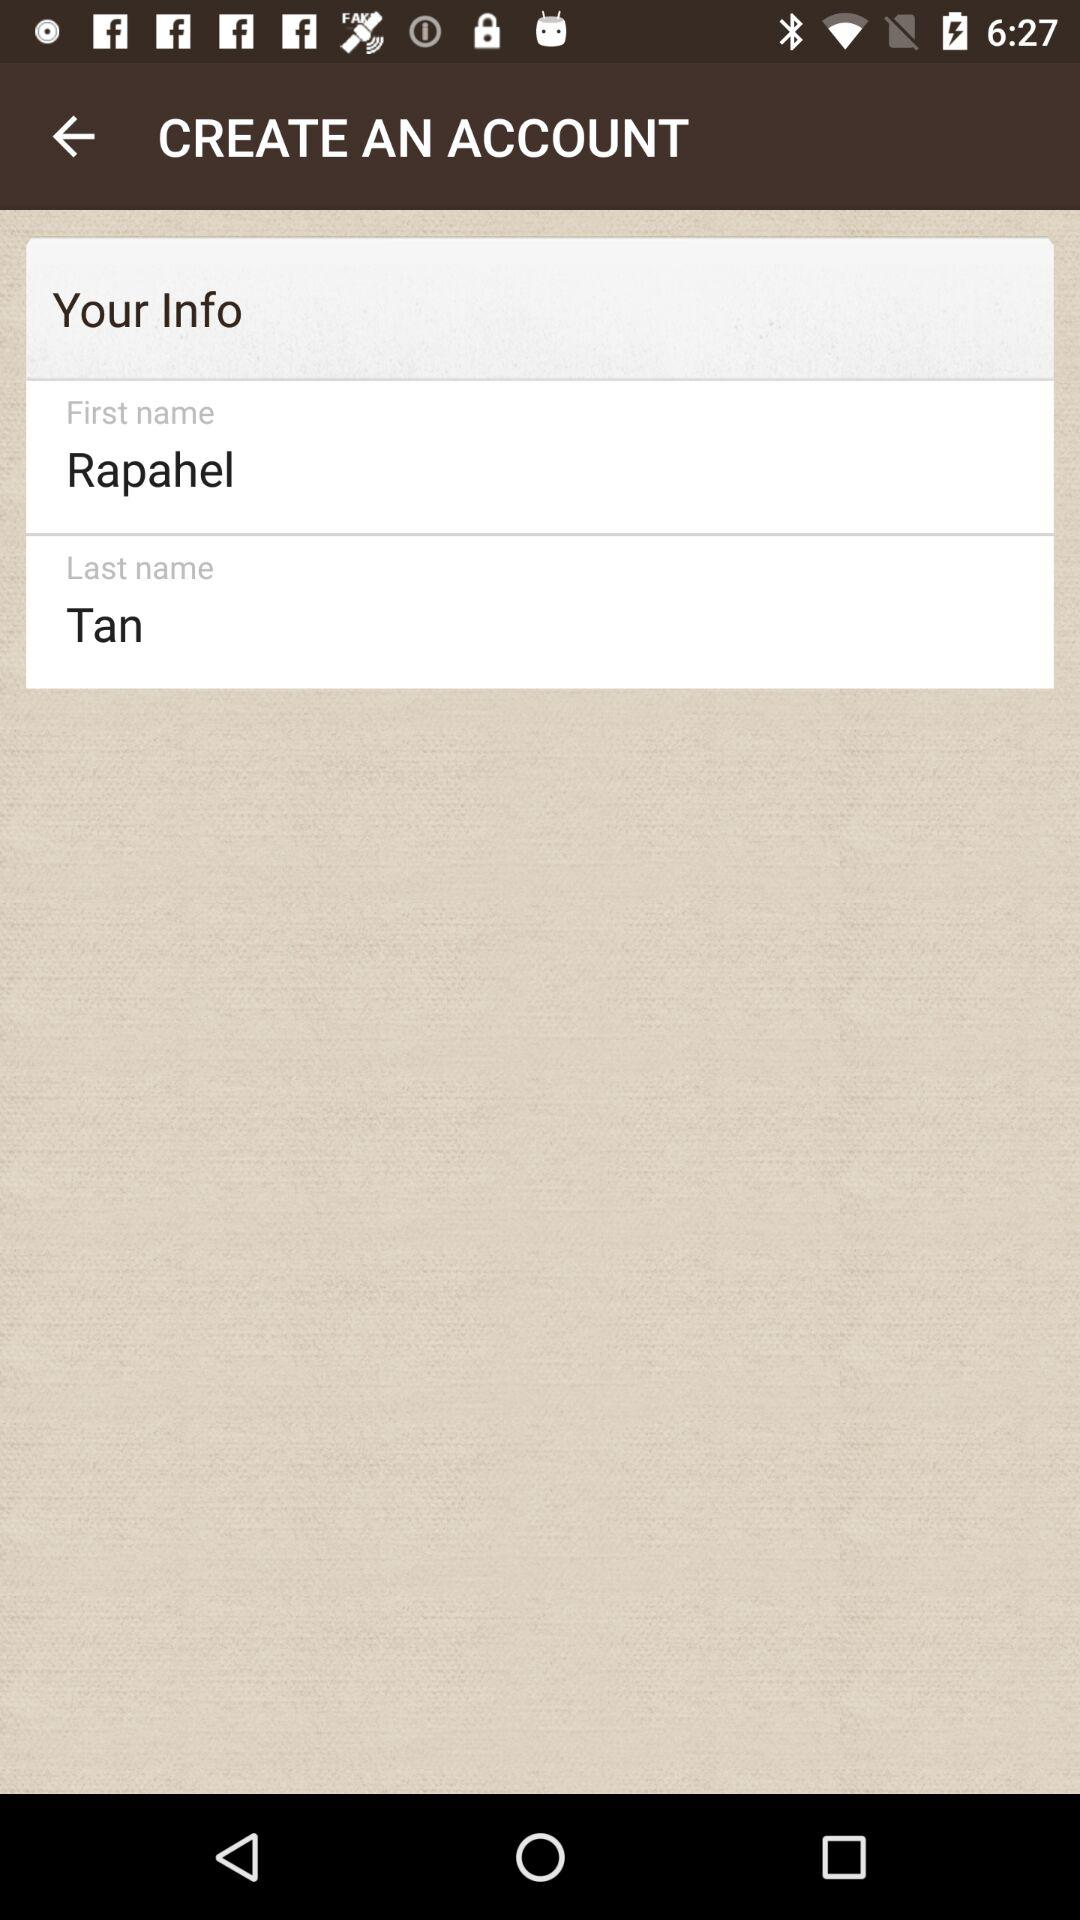What is written in the "Last name"? In the "Last name", Tan is written. 